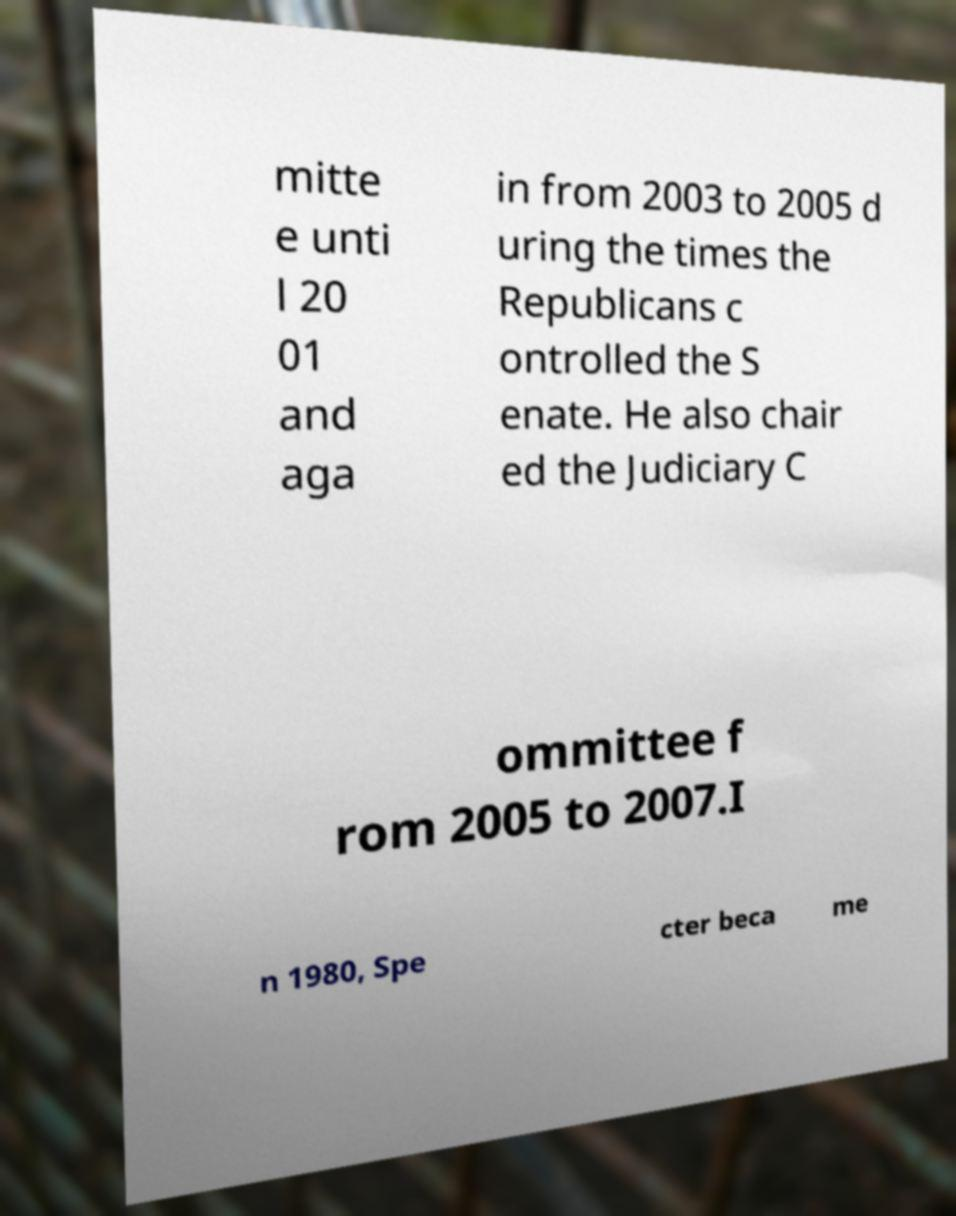What messages or text are displayed in this image? I need them in a readable, typed format. mitte e unti l 20 01 and aga in from 2003 to 2005 d uring the times the Republicans c ontrolled the S enate. He also chair ed the Judiciary C ommittee f rom 2005 to 2007.I n 1980, Spe cter beca me 